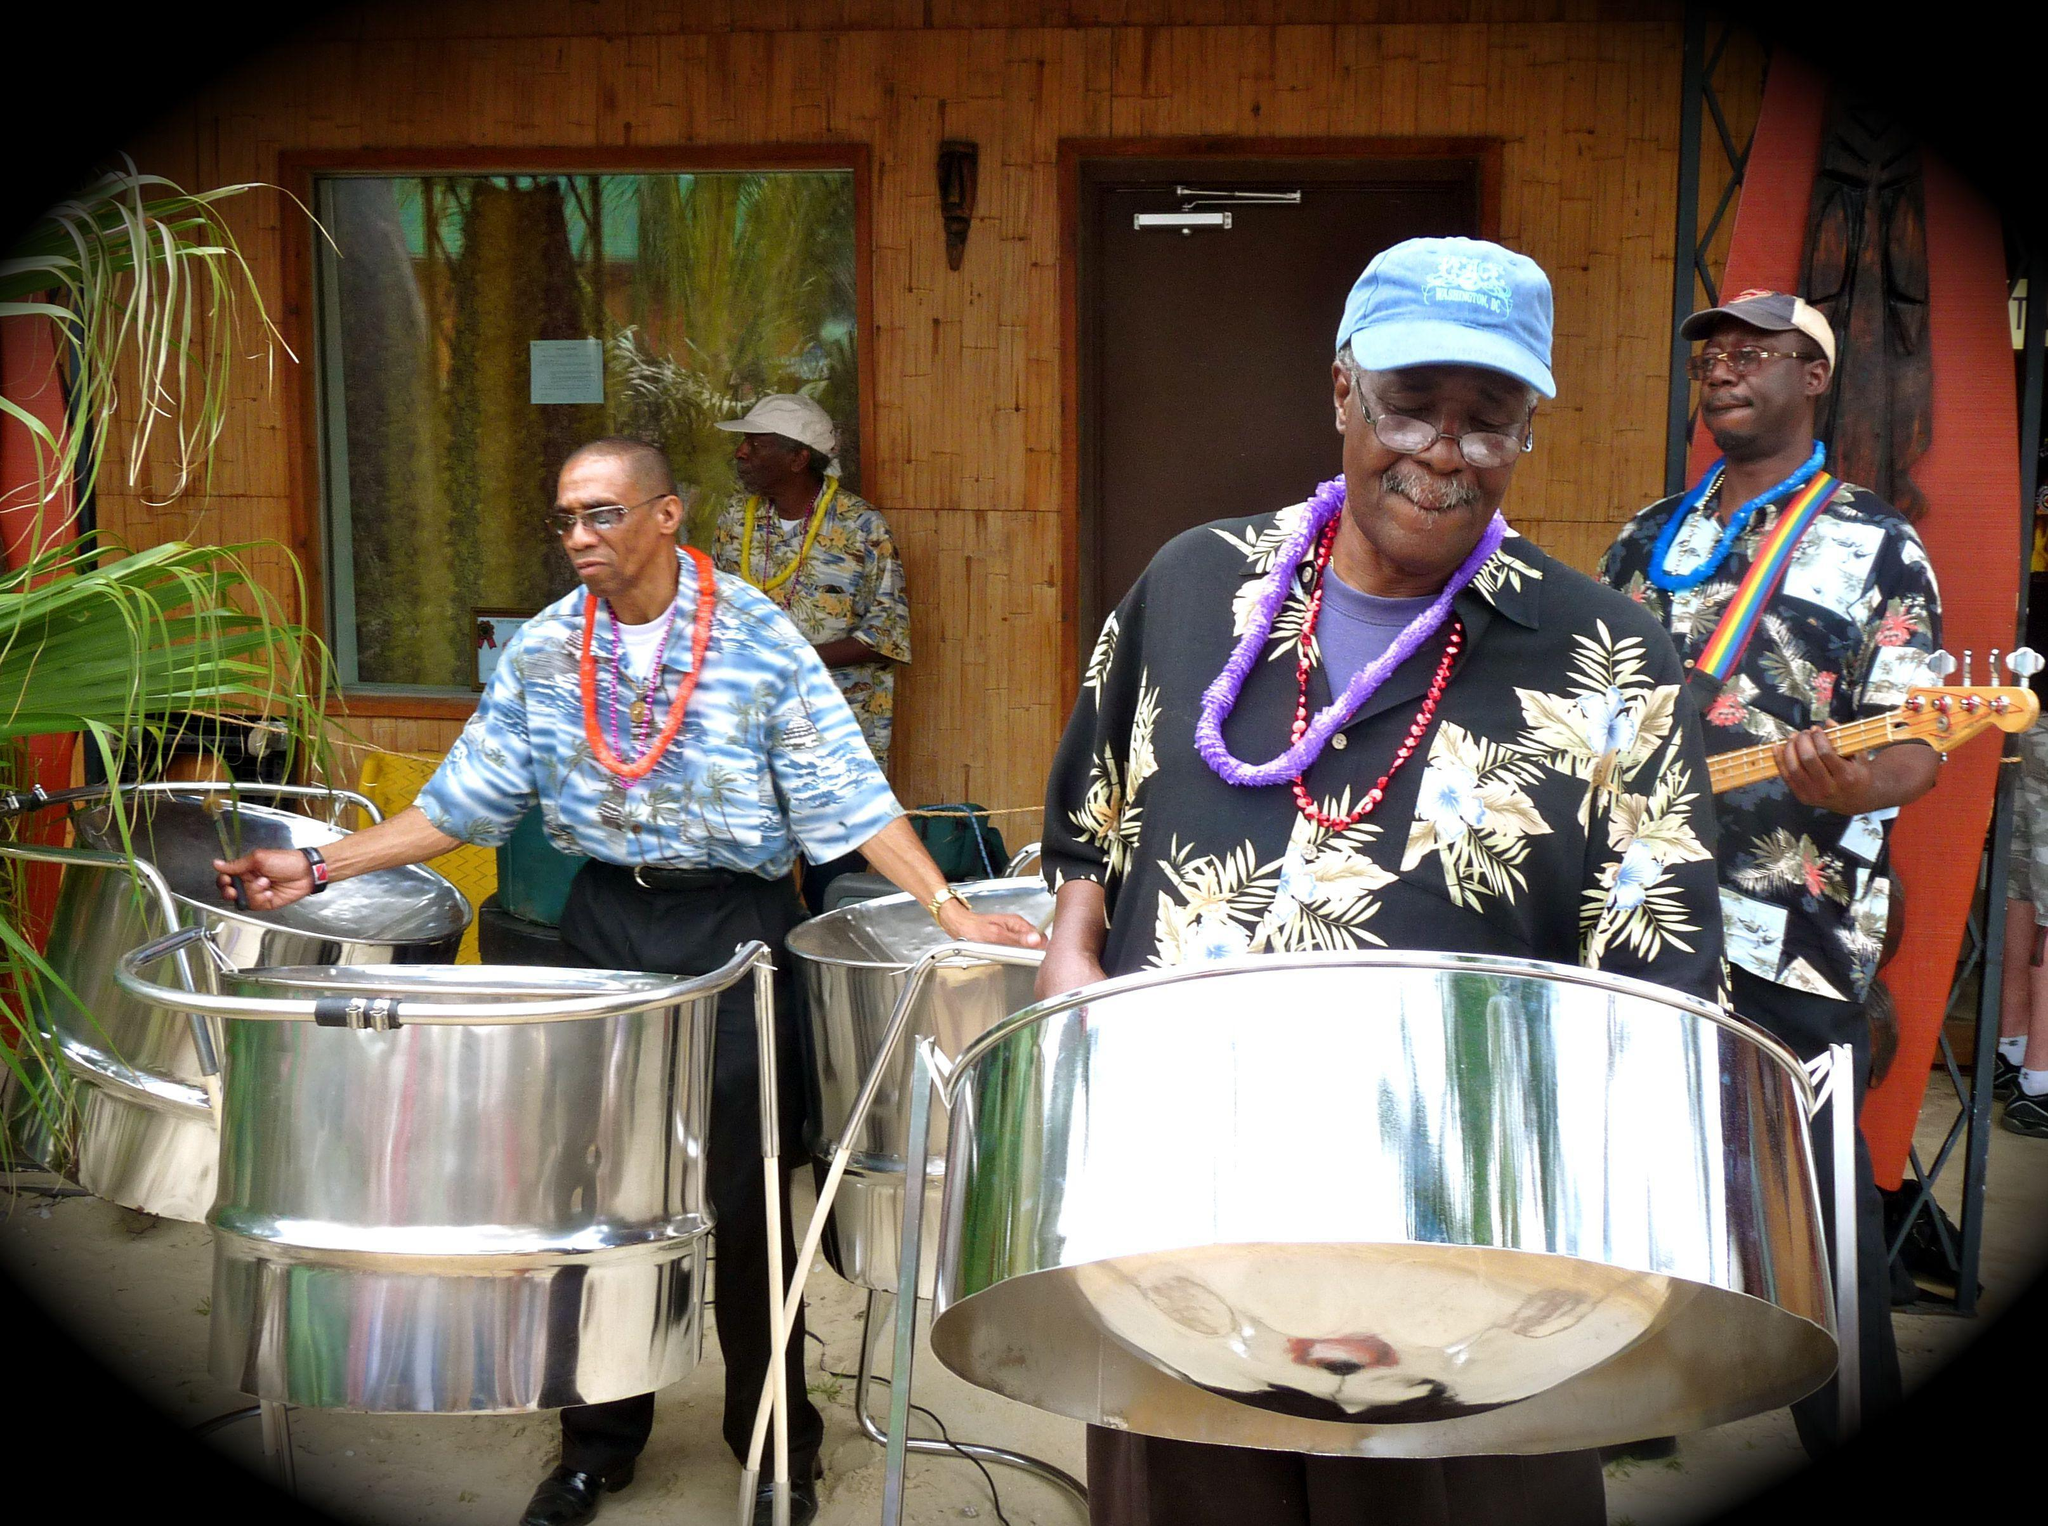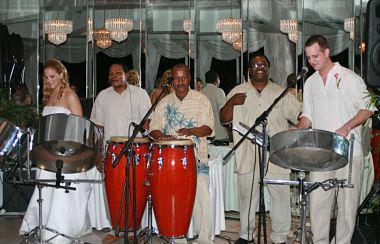The first image is the image on the left, the second image is the image on the right. Considering the images on both sides, is "A drummer is wearing a hat." valid? Answer yes or no. Yes. 